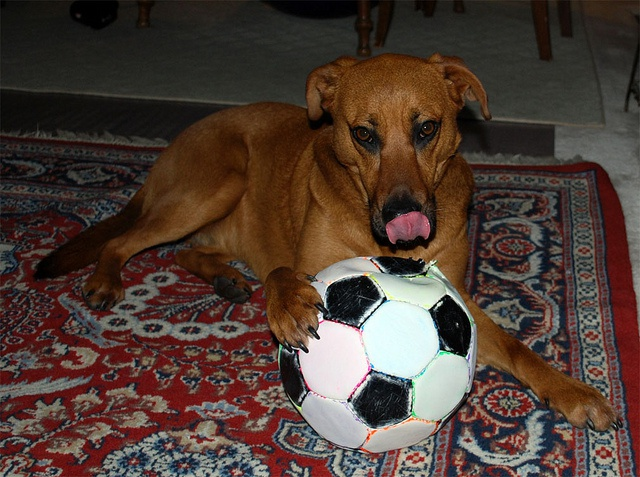Describe the objects in this image and their specific colors. I can see dog in black, maroon, and brown tones, sports ball in black, lightgray, darkgray, and gray tones, chair in black tones, and chair in black tones in this image. 